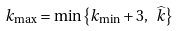<formula> <loc_0><loc_0><loc_500><loc_500>k _ { \max } = \min \left \{ k _ { \min } + 3 , \ \widehat { k } \right \}</formula> 